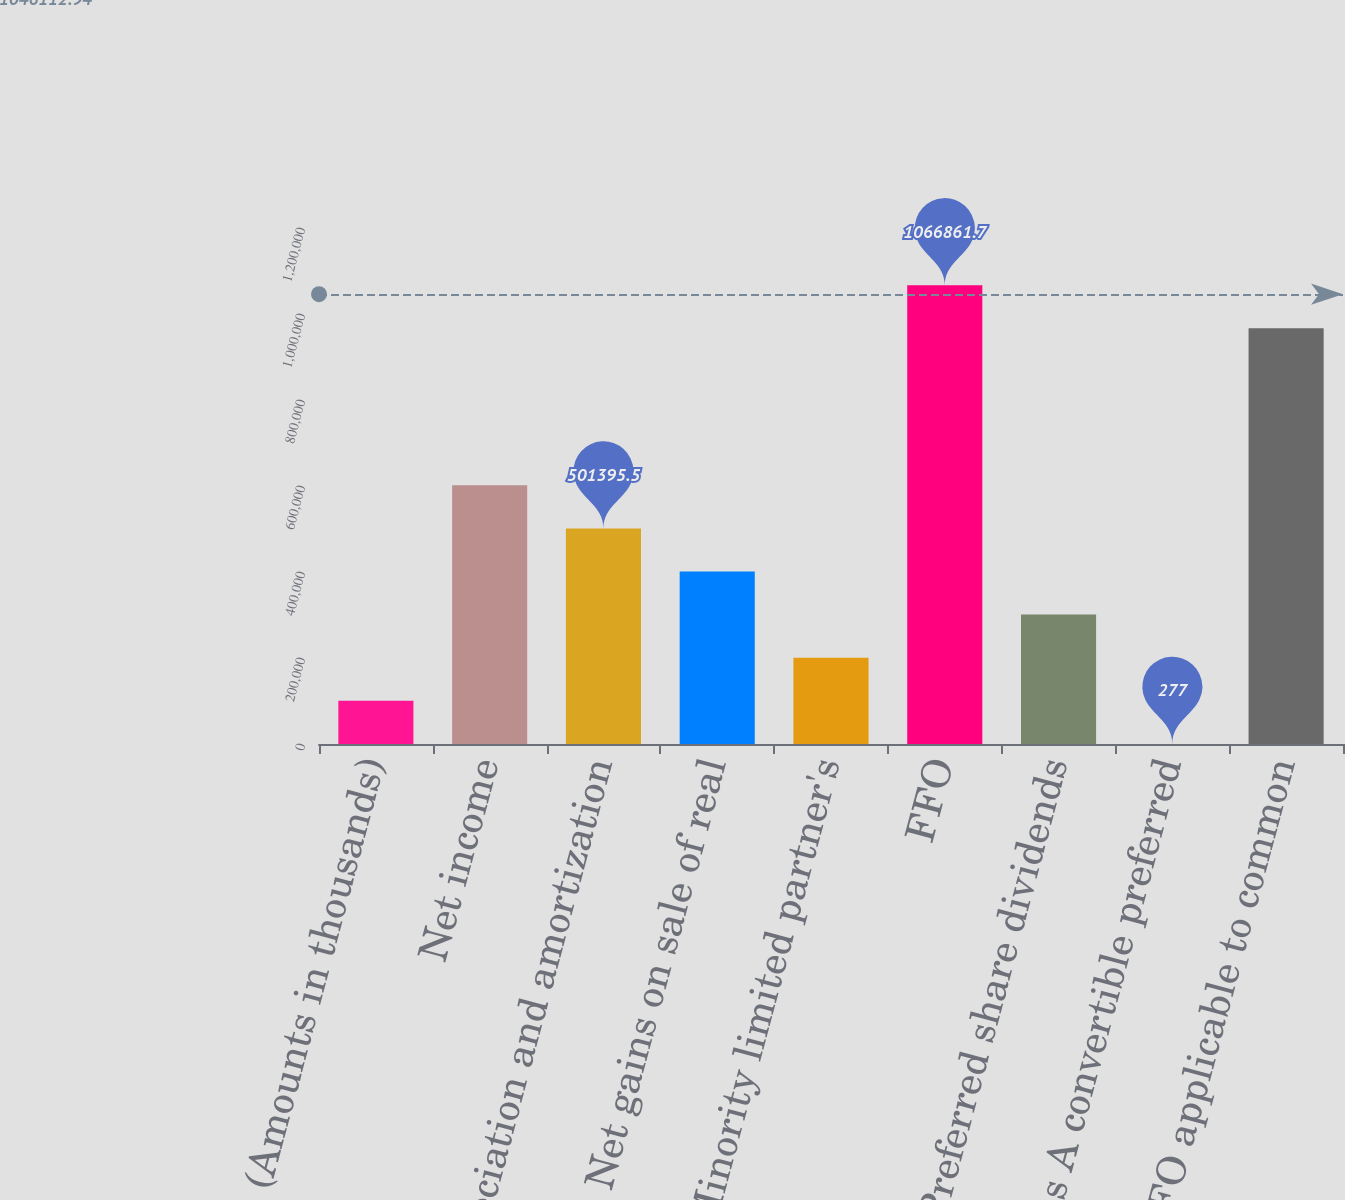<chart> <loc_0><loc_0><loc_500><loc_500><bar_chart><fcel>(Amounts in thousands)<fcel>Net income<fcel>Depreciation and amortization<fcel>Net gains on sale of real<fcel>Minority limited partner's<fcel>FFO<fcel>Preferred share dividends<fcel>Series A convertible preferred<fcel>FFO applicable to common<nl><fcel>100501<fcel>601619<fcel>501396<fcel>401172<fcel>200724<fcel>1.06686e+06<fcel>300948<fcel>277<fcel>966638<nl></chart> 